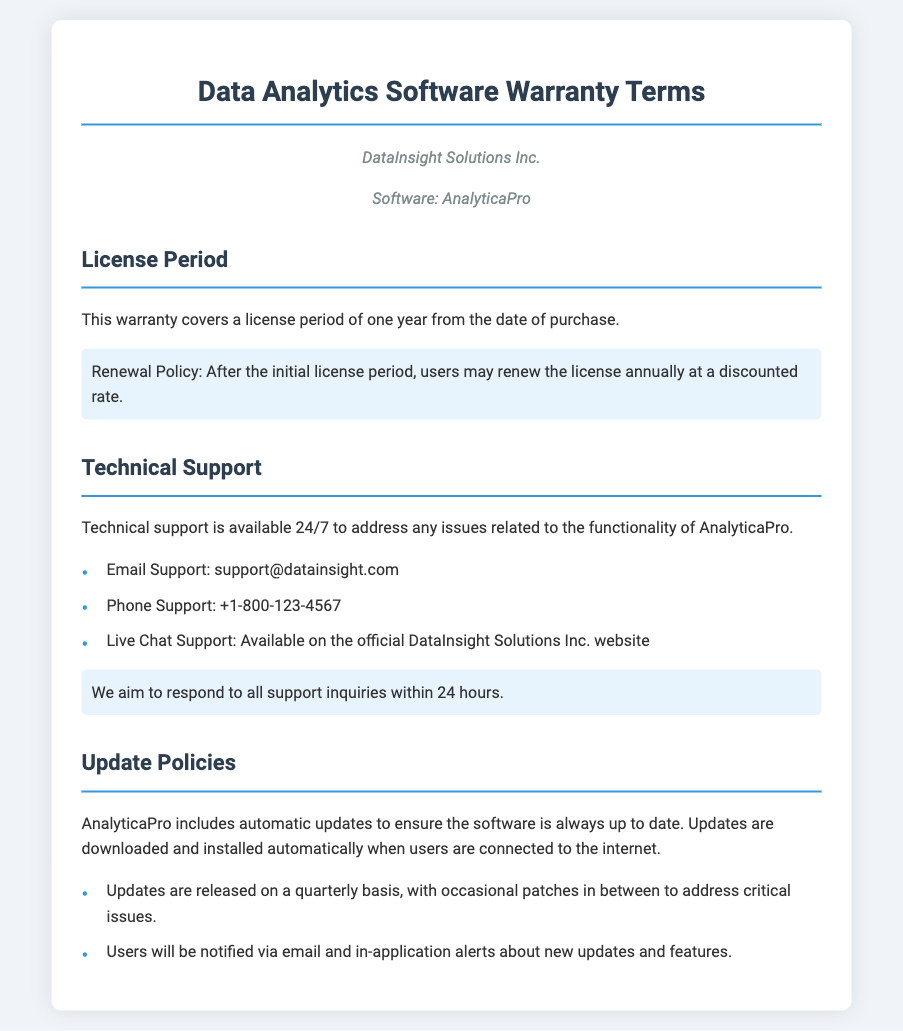What is the name of the software covered by the warranty? The document states that the software is called AnalyticaPro, as mentioned in the company info section.
Answer: AnalyticaPro How long is the warranty license period? The license period is specifically mentioned in the document as one year from the date of purchase.
Answer: one year What is the email support contact? The document provides the email support contact as support@datainsight.com.
Answer: support@datainsight.com How often are software updates released? The document states that updates are released on a quarterly basis.
Answer: quarterly What is the response time for support inquiries? The document highlights that the aim is to respond to all support inquiries within 24 hours.
Answer: 24 hours What is the renewal policy for the license? A discounted rate is offered for users who wish to renew the license annually after the initial period.
Answer: discounted rate Is technical support available during weekends? The document notes that technical support is available 24/7, indicating availability during weekends.
Answer: 24/7 How will users be notified about new updates? Users will be notified via email and in-application alerts about new updates and features.
Answer: email and in-application alerts 